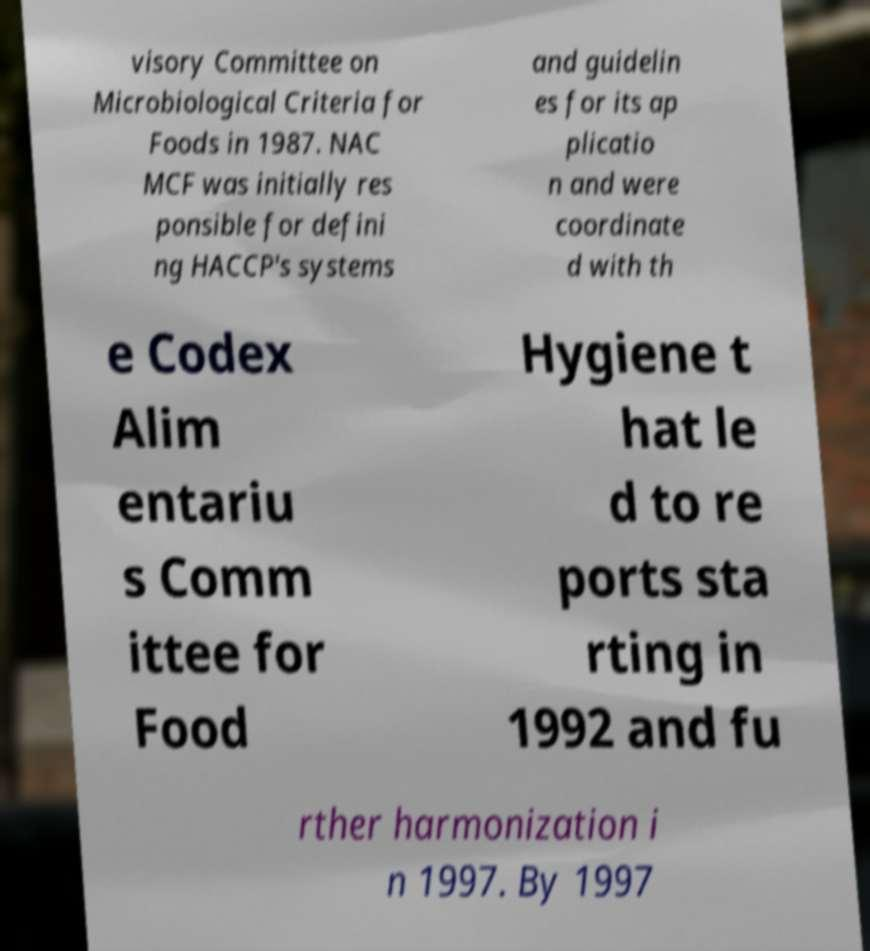Could you extract and type out the text from this image? visory Committee on Microbiological Criteria for Foods in 1987. NAC MCF was initially res ponsible for defini ng HACCP's systems and guidelin es for its ap plicatio n and were coordinate d with th e Codex Alim entariu s Comm ittee for Food Hygiene t hat le d to re ports sta rting in 1992 and fu rther harmonization i n 1997. By 1997 